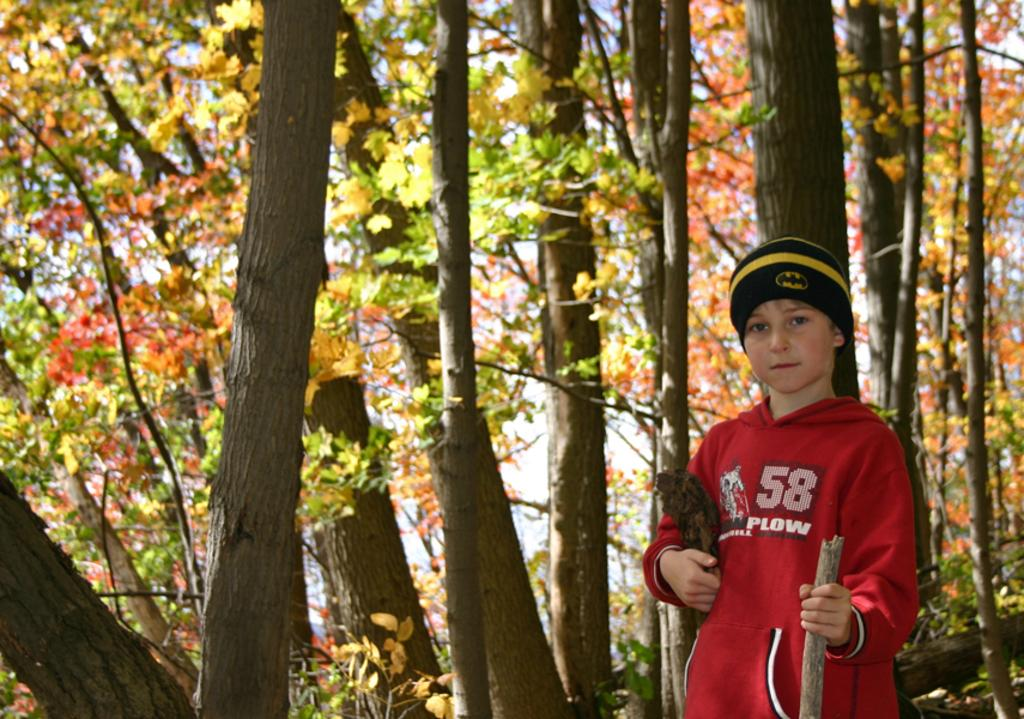Who is the main subject in the image? There is a boy in the image. What is the boy holding in his hands? The boy is holding a stick and an object in his hands. What can be seen in the background of the image? There are trees visible in the image. What type of tax is being discussed in the image? There is no discussion of tax in the image; it features a boy holding a stick and an object. What kind of nut is visible in the image? There is no nut present in the image. 